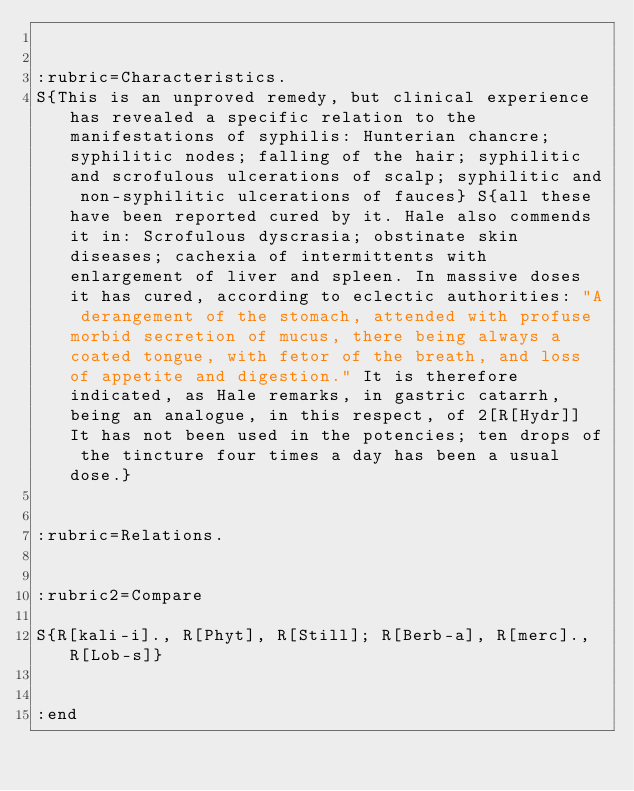<code> <loc_0><loc_0><loc_500><loc_500><_ObjectiveC_>

:rubric=Characteristics.
S{This is an unproved remedy, but clinical experience has revealed a specific relation to the manifestations of syphilis: Hunterian chancre; syphilitic nodes; falling of the hair; syphilitic and scrofulous ulcerations of scalp; syphilitic and non-syphilitic ulcerations of fauces} S{all these have been reported cured by it. Hale also commends it in: Scrofulous dyscrasia; obstinate skin diseases; cachexia of intermittents with enlargement of liver and spleen. In massive doses it has cured, according to eclectic authorities: "A derangement of the stomach, attended with profuse morbid secretion of mucus, there being always a coated tongue, with fetor of the breath, and loss of appetite and digestion." It is therefore indicated, as Hale remarks, in gastric catarrh, being an analogue, in this respect, of 2[R[Hydr]] It has not been used in the potencies; ten drops of the tincture four times a day has been a usual dose.}


:rubric=Relations.


:rubric2=Compare

S{R[kali-i]., R[Phyt], R[Still]; R[Berb-a], R[merc]., R[Lob-s]}

  
:end</code> 